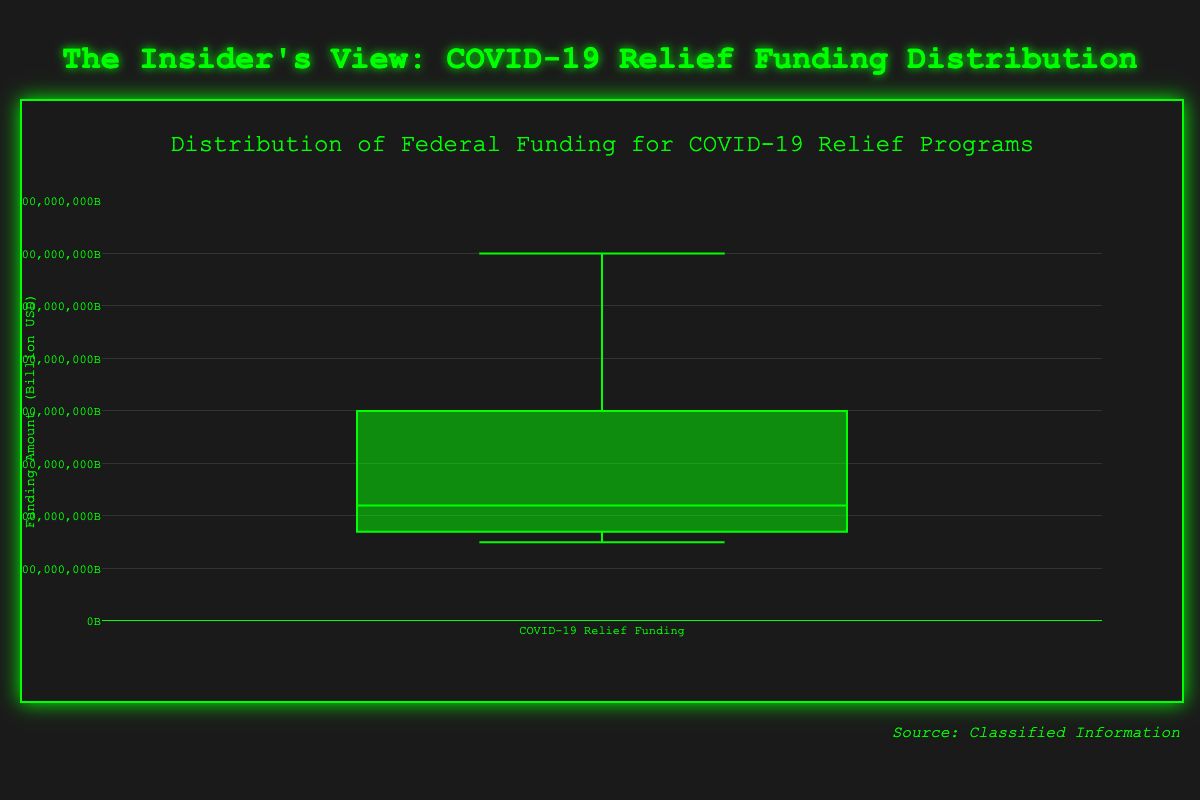What is the title of the figure? The title of the figure can be found at the top of the visualization.
Answer: Distribution of Federal Funding for COVID-19 Relief Programs What is the maximum funding amount shown in the plot? The maximum funding amount is the highest whisker or outlier point on the box plot.
Answer: 35 billion USD Which state received the highest amount of federal funding for COVID-19 relief? The data labels the funding amount for each state, with the highest being 35 billion USD for California.
Answer: California Which state received the least amount of federal funding for COVID-19 relief? The data identifies the lowest funding figure, which is 7.5 billion USD for North Carolina.
Answer: North Carolina What is the median value of federal funding for COVID-19 relief across the states? The median value is represented by the line inside the box of the box plot, indicating the midpoint of the data distribution.
Answer: 10 billion USD What is the range of federal funding shown in the plot? The range is calculated by subtracting the smallest funding amount from the largest. 35 billion USD (highest) - 7.5 billion USD (lowest).
Answer: 27.5 billion USD Which state received more funding: Ohio or Michigan? By comparing the funding amounts, Ohio received 8 billion USD, and Michigan received 8.5 billion USD.
Answer: Michigan How many states received more than 20 billion USD in federal funding for COVID-19 relief? By counting the states with funding amounts over 20 billion USD, you find California, Texas, and New York.
Answer: 3 states Other than California, which state received the most federal funding? Comparing the funding amounts excluding California, the next highest is 30 billion USD by New York.
Answer: New York What is the interquartile range (IQR) of the federal funding distribution? The IQR is the difference between the third quartile (Q3) and the first quartile (Q1) values in the box plot.
Answer: 11.25 billion USD 